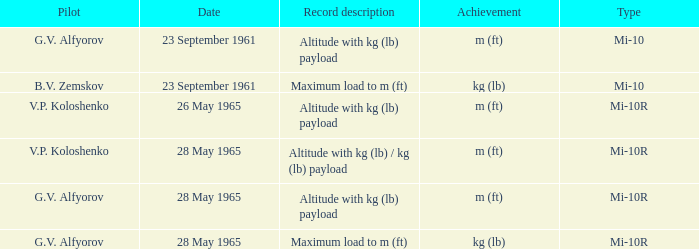Type of mi-10r, and a Record description of altitude with kg (lb) payload, and a Pilot of g.v. alfyorov is what date? 28 May 1965. 